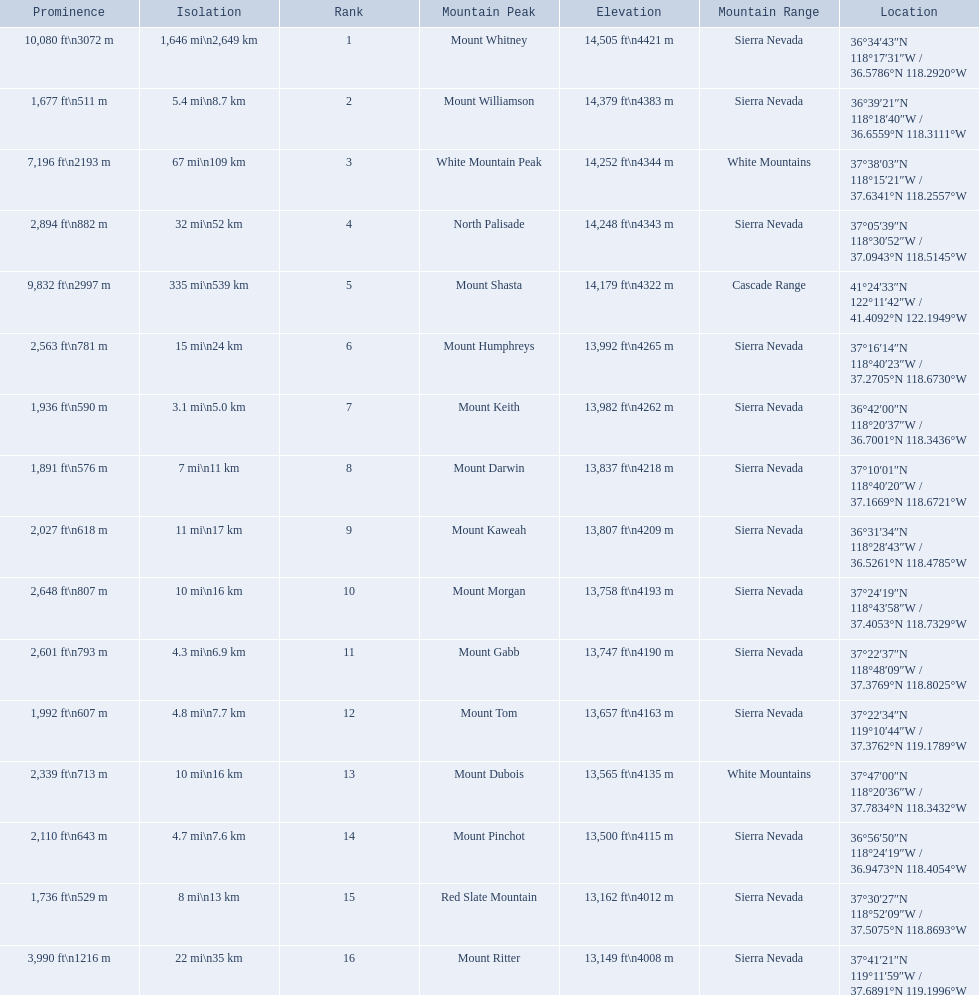What are the heights of the californian mountain peaks? 14,505 ft\n4421 m, 14,379 ft\n4383 m, 14,252 ft\n4344 m, 14,248 ft\n4343 m, 14,179 ft\n4322 m, 13,992 ft\n4265 m, 13,982 ft\n4262 m, 13,837 ft\n4218 m, 13,807 ft\n4209 m, 13,758 ft\n4193 m, 13,747 ft\n4190 m, 13,657 ft\n4163 m, 13,565 ft\n4135 m, 13,500 ft\n4115 m, 13,162 ft\n4012 m, 13,149 ft\n4008 m. What elevation is 13,149 ft or less? 13,149 ft\n4008 m. What mountain peak is at this elevation? Mount Ritter. 